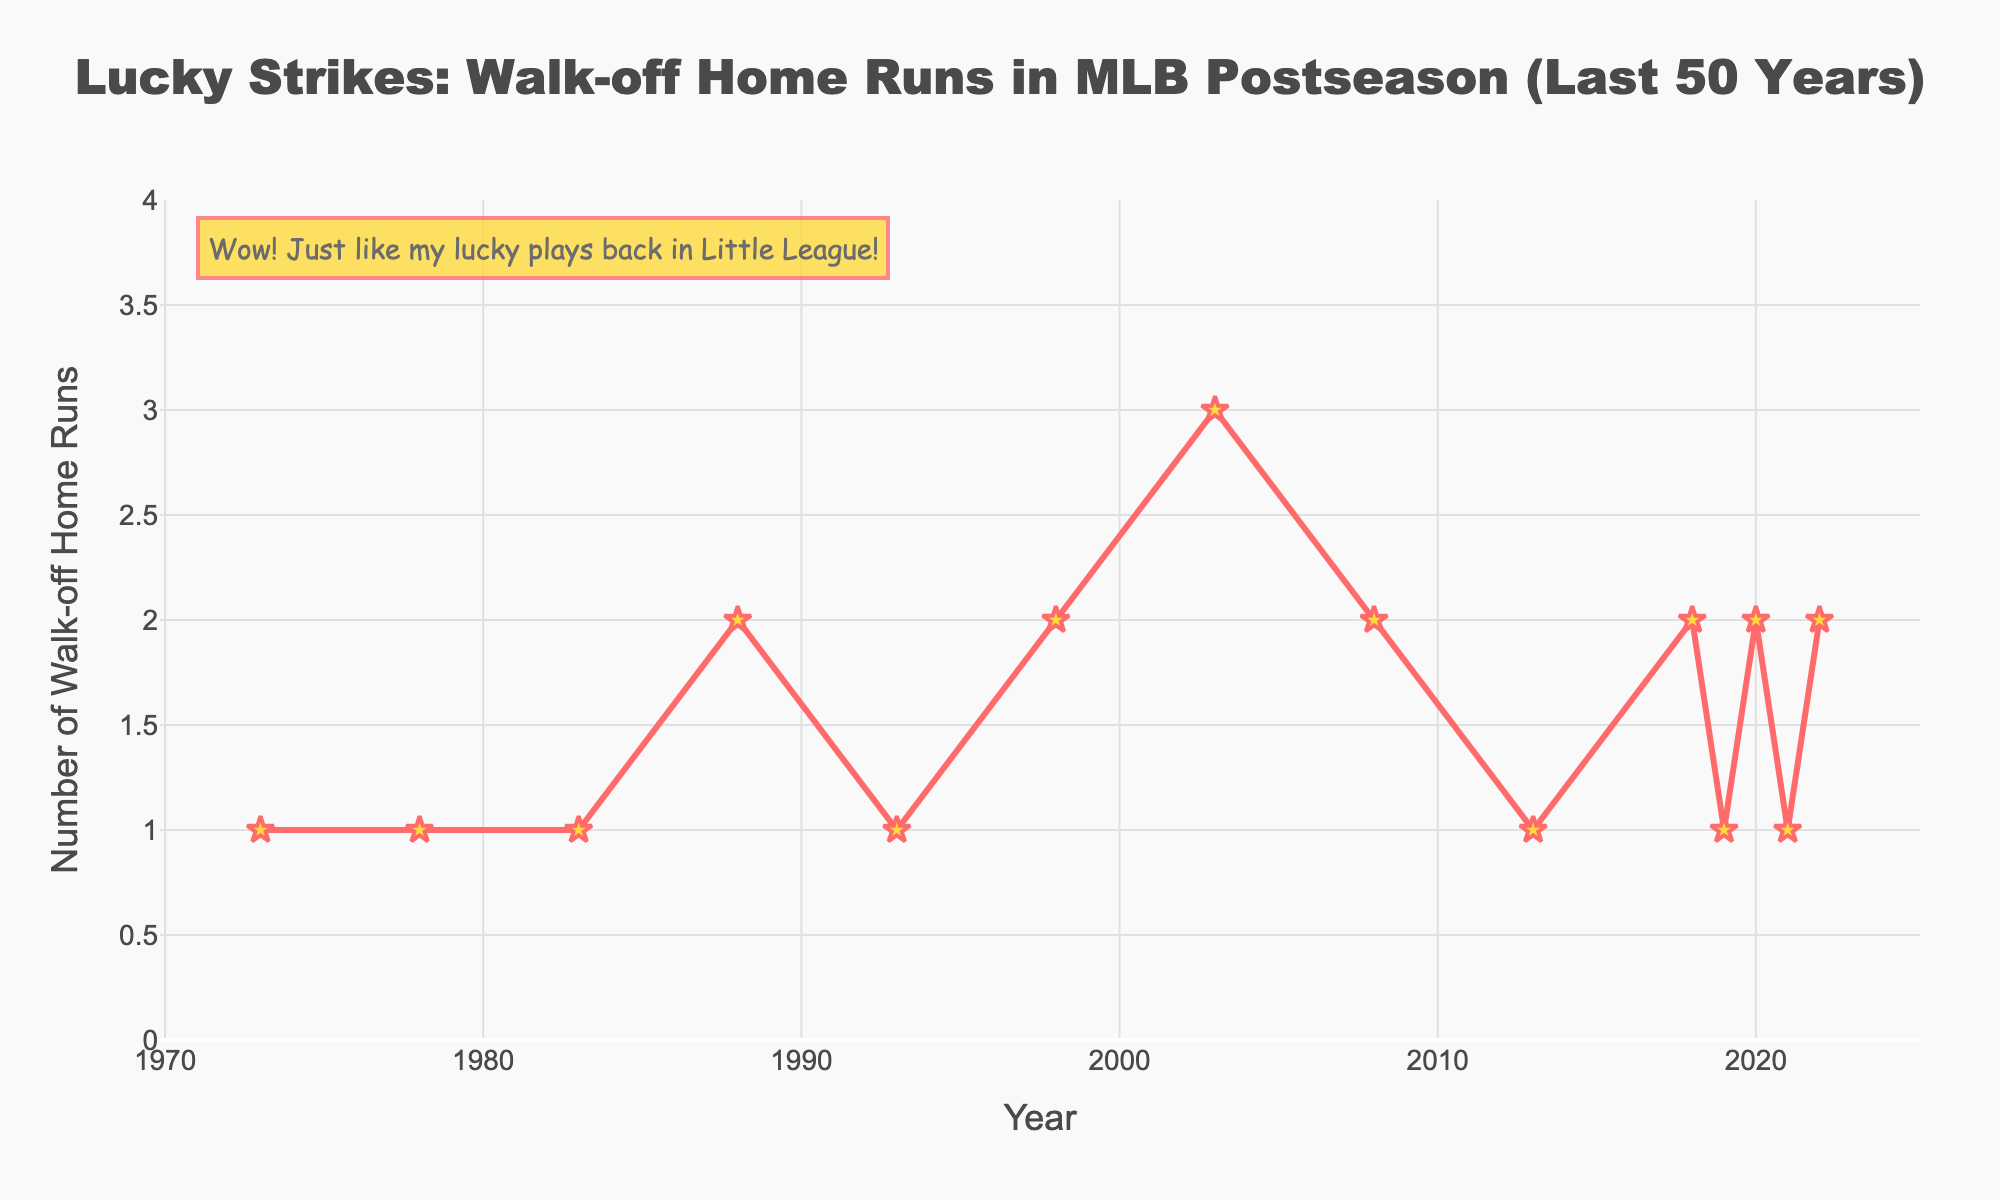Which year had the highest occurrence of walk-off home runs? The year with the highest peak on the line chart represents the year with the highest occurrence of walk-off home runs. By visually inspecting the graph, the year 2003 stands out as having the highest peak.
Answer: 2003 Compare the number of walk-off home runs in 1978 and 2022. Which year had more? By observing the y-values corresponding to the years 1978 and 2022 on the x-axis, we see that 1978 had 1 and 2022 had 2 walk-off home runs.
Answer: 2022 What is the range in the number of walk-off home runs from 1973 to 2022? The range is found by subtracting the minimum value from the maximum value. The minimum number shown on the y-axis is 1 and the maximum is 3. Thus, the range is 3 - 1.
Answer: 2 How many times did the occurrence of walk-off home runs reach exactly 2? Count the number of times the line chart hits the value of 2 on the y-axis. Based on the data points, this happens in the years 1988, 1998, 2008, 2018, 2020, 2022.
Answer: 6 Was there any 5-year period with consistent occurrences of walk-off home runs? To determine this, note if there is any period of five consecutive data points with the same y-value. By checking the dataset in sequential 5-year intervals, no such period with consistent occurrences is observed.
Answer: No When was the last occurrence of a walk-off home run before 2020? By looking at the data points plotted on the x-axis, the last year before 2020 with walk-off home runs is 2019.
Answer: 2019 In which decade did the number of walk-off home runs increase the most significantly? Calculate the difference in the number of walk-off home runs between the start and end of each decade. The largest noticeable increase was from the 2000s, starting at 2 in 2008 and peaking at 3 in 2003.
Answer: 2000s What is the average number of walk-off home runs per recorded year? To find the average, sum up the walk-off home runs and divide by the number of years in the dataset. The sum of the numbers is 24 (1+1+1+2+1+2+3+2+1+2+1+2+1+2). Dividing this by 14 years equals approximately 1.71.
Answer: 1.71 Did any year record just one walk-off home run for two consecutive periods? Check the sequence of data points for an occurrence where there are two consecutive periods of the y-value being 1. The years 1973, 1978, 1983, and 1993 each recorded one walk-off home run without consecutive repetition immediately following another.
Answer: No 